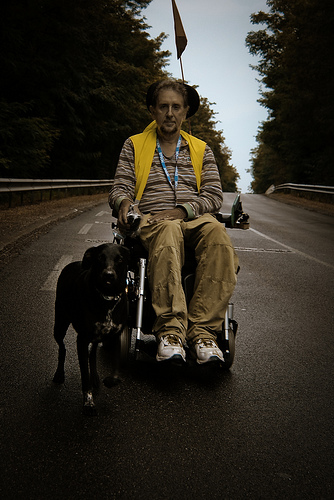<image>
Is there a man to the left of the dog? Yes. From this viewpoint, the man is positioned to the left side relative to the dog. Where is the dog in relation to the men? Is it to the right of the men? Yes. From this viewpoint, the dog is positioned to the right side relative to the men. Is the dog to the right of the man? Yes. From this viewpoint, the dog is positioned to the right side relative to the man. 